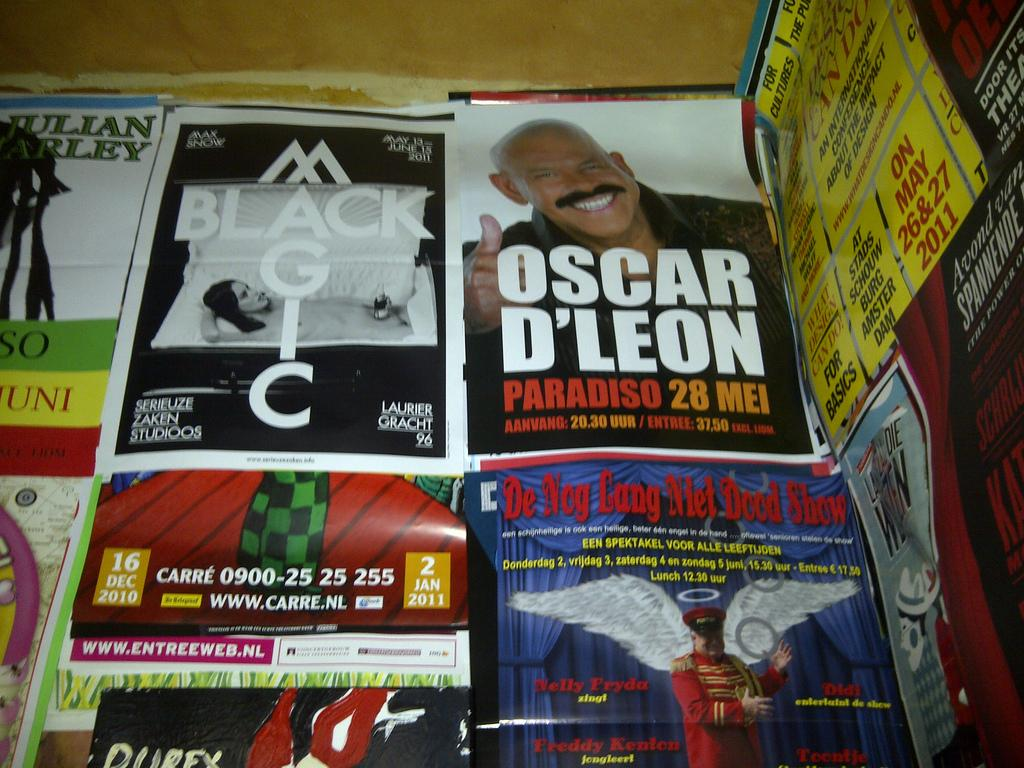<image>
Write a terse but informative summary of the picture. A picture of Oscar D'Leon is featured on the page of a magazine. 